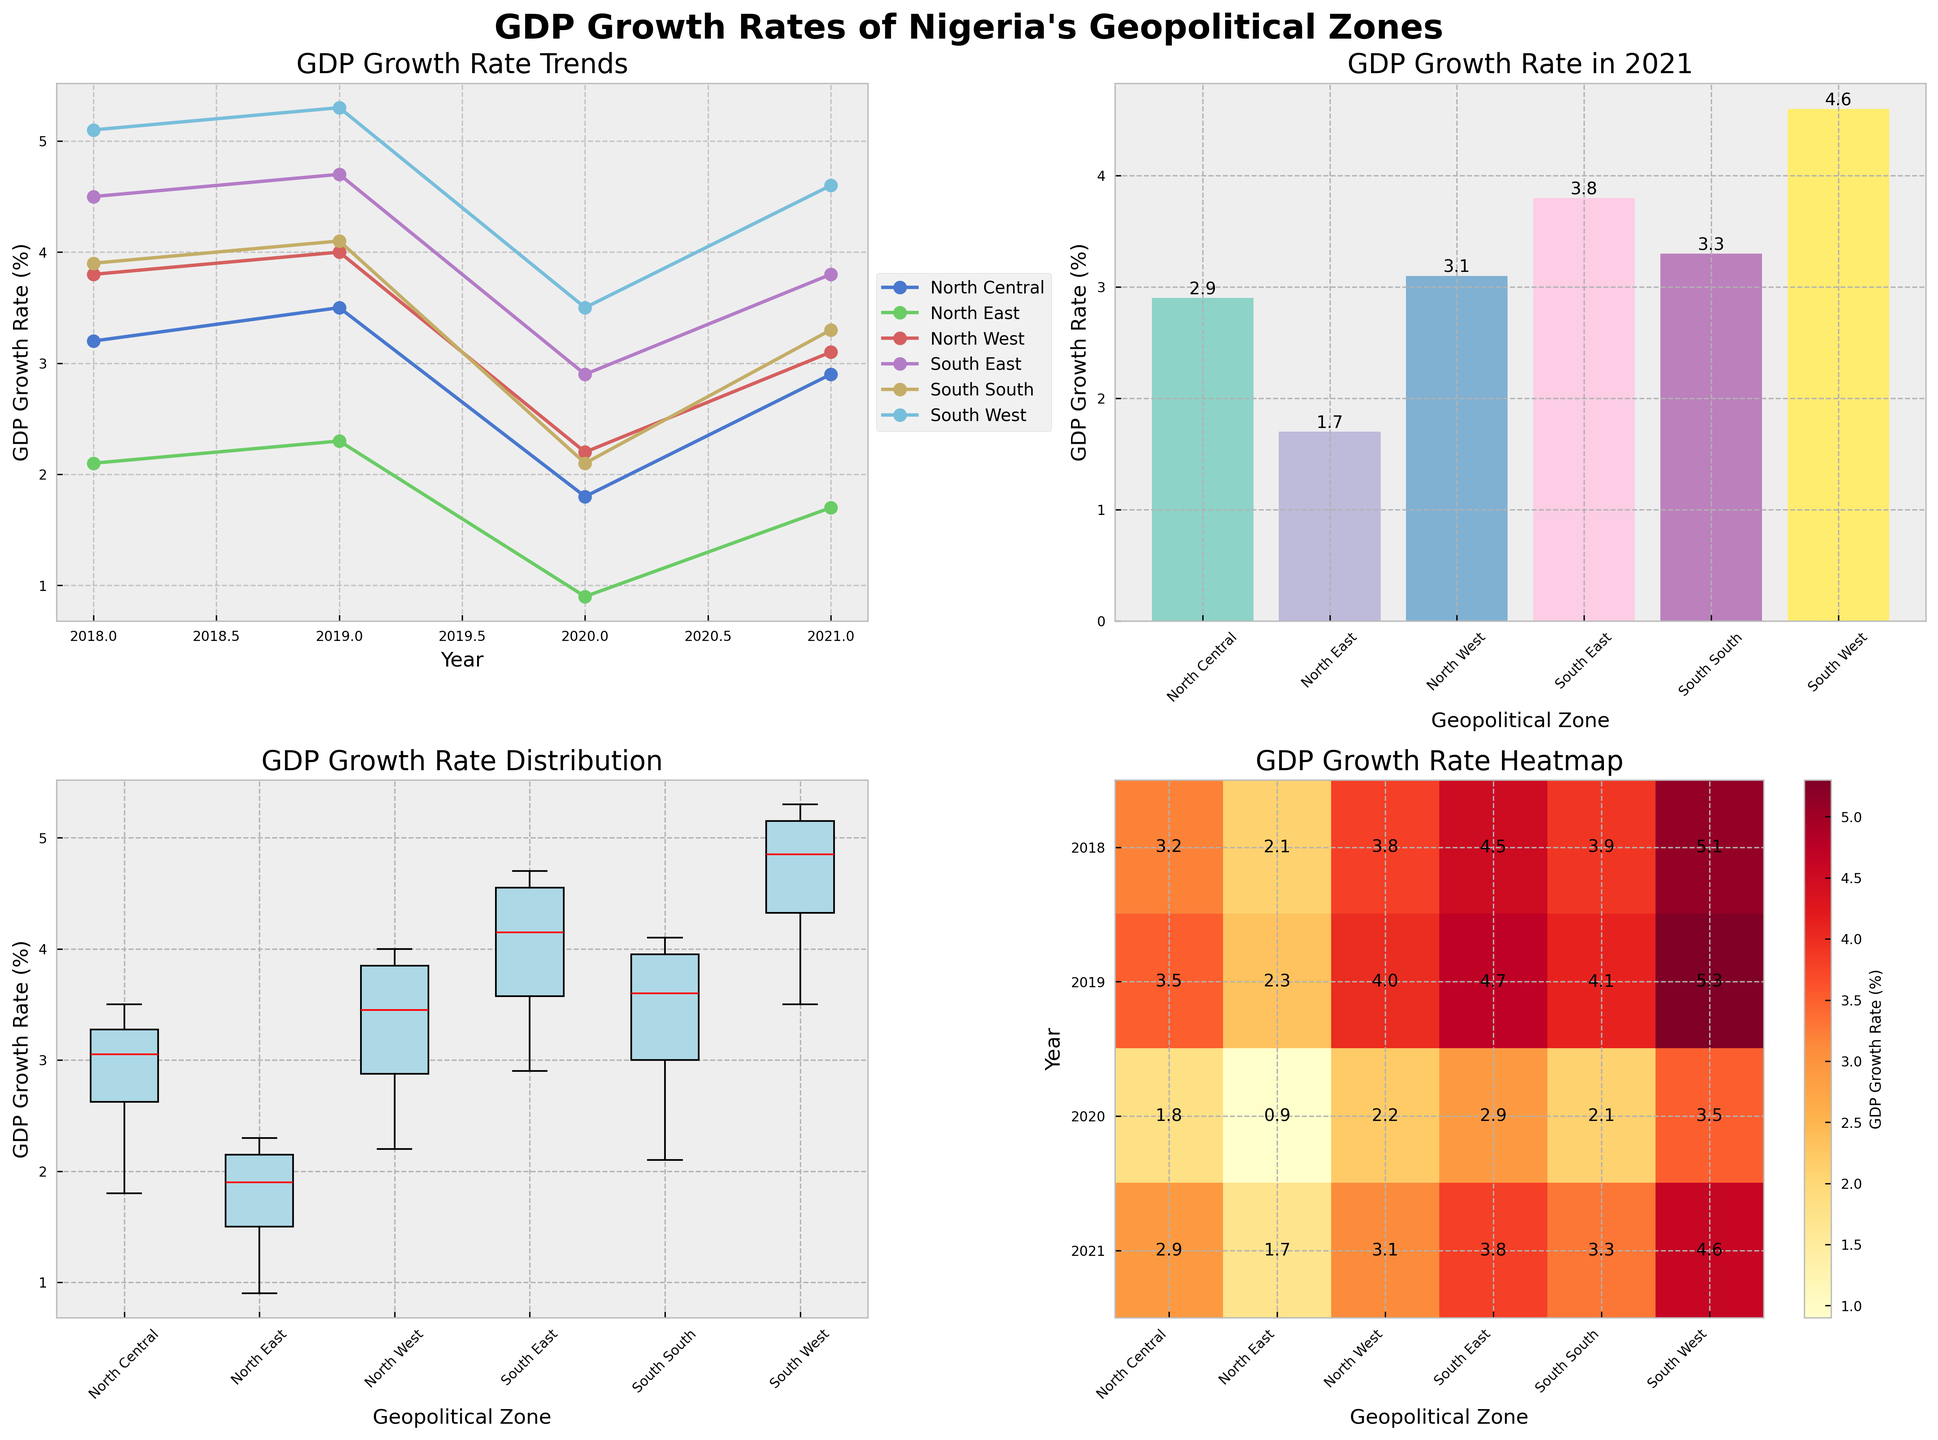What trend can be observed for the GDP growth rate of the South West zone from 2018 to 2021? The line plot shows the GDP growth rates of various zones over different years. Looking at the South West zone, we can see that the GDP growth rate remains consistently the highest and shows a slight decrease from 2018 to 2020, followed by an increase in 2021.
Answer: A slight decrease from 2018 to 2020, then an increase in 2021 In the most recent year, which zone had the lowest GDP growth rate? The bar plot for the year 2021 shows the GDP growth rates of different zones. The North East zone has the lowest GDP growth rate, which is visible by the shortest bar.
Answer: North East What is the median GDP growth rate for the South East zone across the years presented? The box plot shows the distribution of GDP growth rates for each zone. For the South East zone, the median is represented by the red line inside the box, which is approximately midway between the lower and upper quartile boundaries.
Answer: Approximately 4.35% How does the GDP growth rate of the North East zone in 2020 compare to other zones in the same year? The heatmap allows us to visually compare the GDP growth rates across different zones and years. For the year 2020, the North East zone has the lowest GDP growth rate compared to other zones in Nigeria.
Answer: It is the lowest Which zone experienced the highest overall GDP growth rate trend over the years 2018 to 2021? The line plot provides a clear view of the GDP growth rate trends over the years for each zone. The South West zone shows the overall highest GDP growth trend from 2018 to 2021.
Answer: South West What was the average GDP growth rate across all zones in 2020? To find the average GDP growth rate across all zones in 2020, sum up the GDP growth rates for each zone in 2020 and divide by the number of zones. The rates are North Central (1.8), North East (0.9), North West (2.2), South East (2.9), South South (2.1), and South West (3.5). The average is (1.8+0.9+2.2+2.9+2.1+3.5) / 6 = 13.4 / 6 = 2.23.
Answer: 2.23% Which year had the highest median GDP growth rate among all zones? By examining the box plot, the overall median GDP growth rate for each year is not directly visible. However, looking at the individual median values for each zone across the years through the lines inside the boxes can help determine the highest. The year 2019 generally shows higher median values across several zones.
Answer: 2019 How did the North West and North East zones' GDP growth rates differ in 2018 and 2020? Using the line plot or heatmap, compare the GDP growth rates for these two zones in both years. In 2018, the North West (3.8) had a much higher growth rate compared to the North East (2.1). Similarly, in 2020, the North West (2.2) had a higher growth rate compared to the North East (0.9).
Answer: North West had higher growth rates in both years Which zone's GDP growth rate showed the most variability over the years 2018 to 2021? The box plot provides a clear view of the variability in GDP growth rates. The width of the boxes and the length of the whiskers indicate variability. The South West and North East zones appear to show significant variability. However, the South West shows a wider range of variability.
Answer: South West 